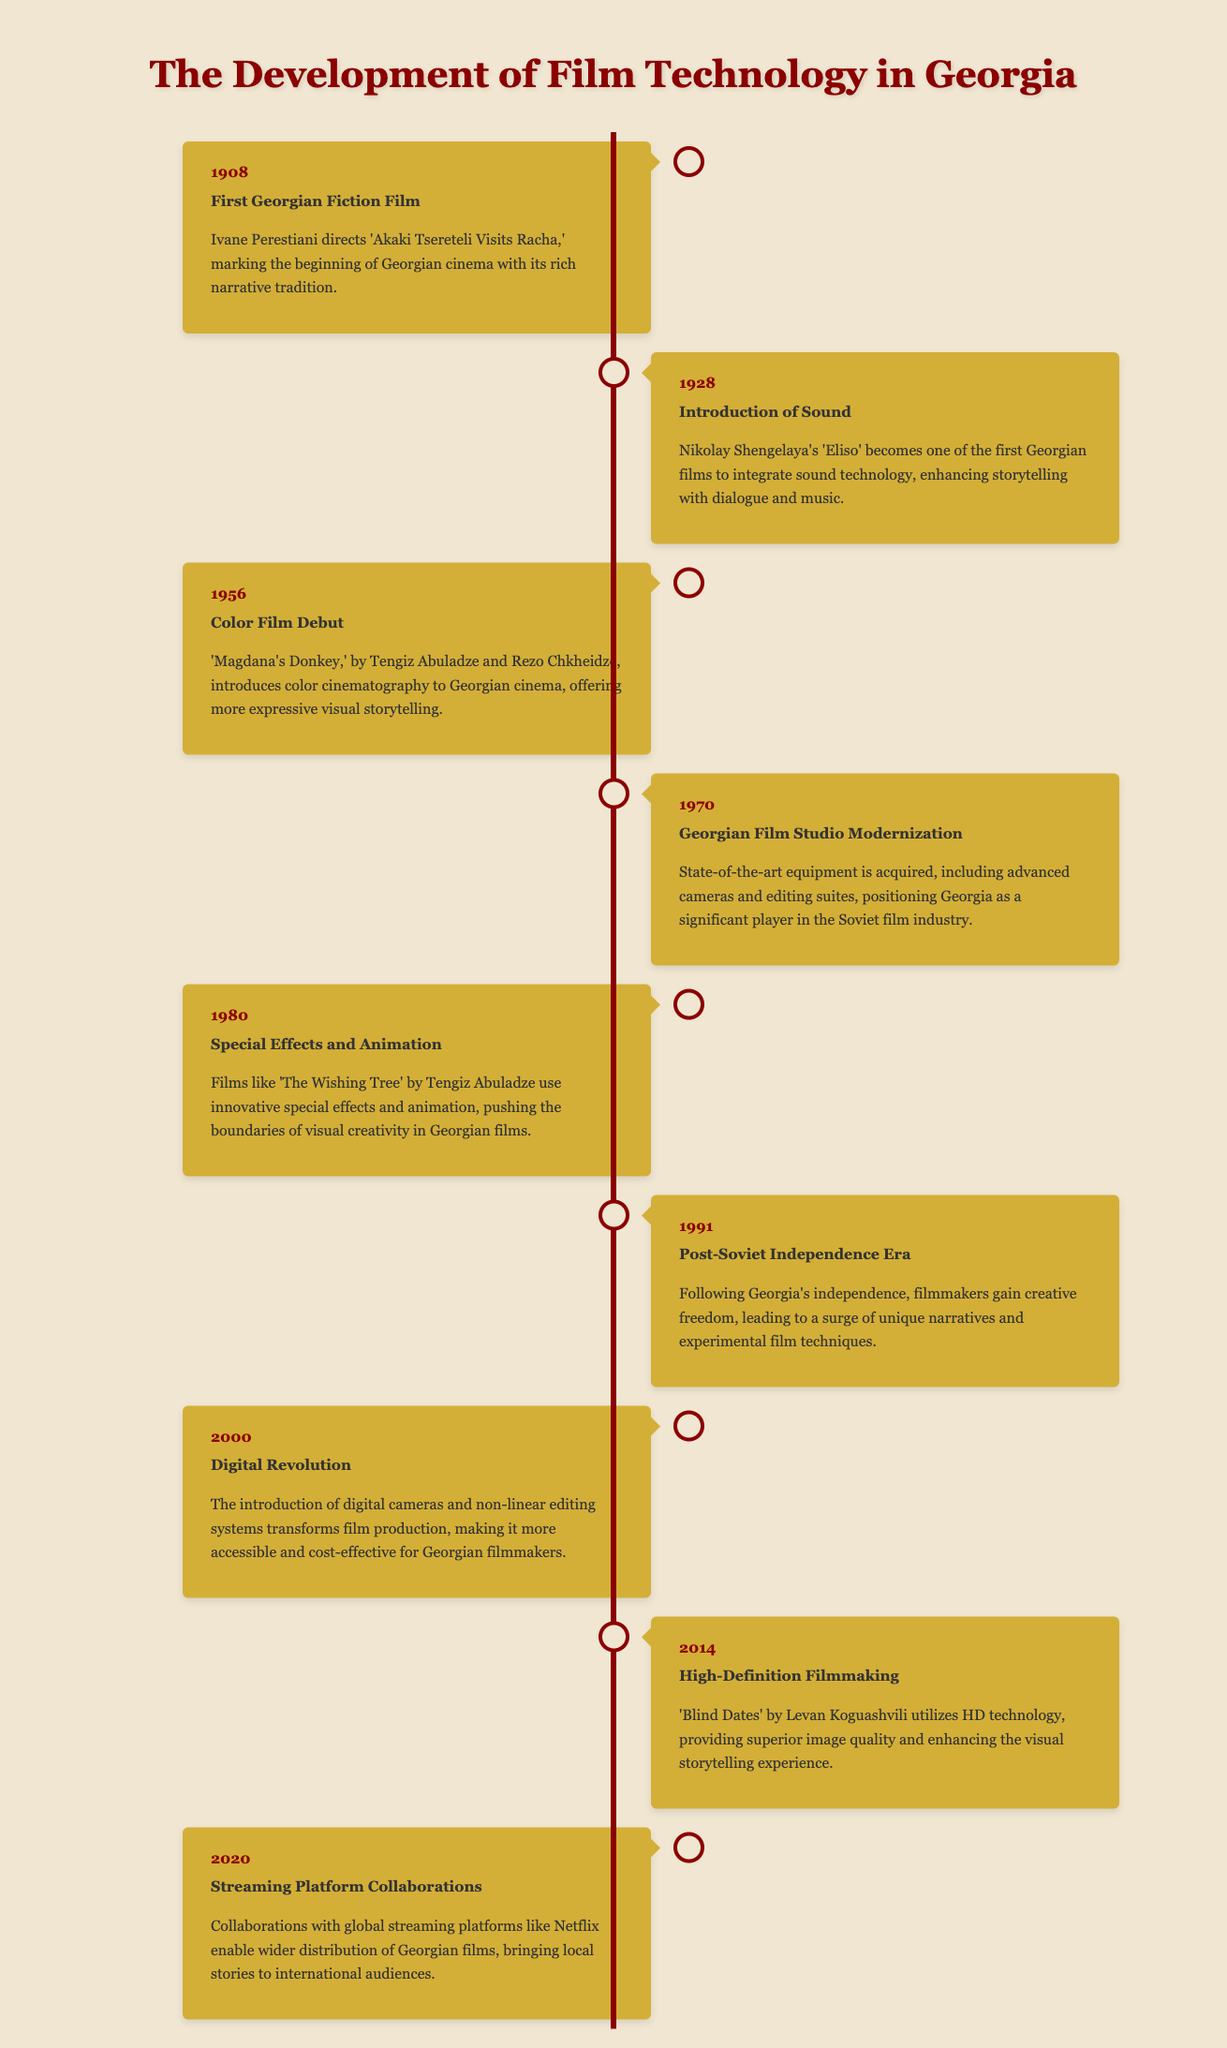What is the title of the first Georgian fiction film? The first Georgian fiction film is 'Akaki Tsereteli Visits Racha,' directed by Ivane Perestiani in 1908.
Answer: 'Akaki Tsereteli Visits Racha' In which year did Georgia integrate sound technology into films? The year when sound technology was integrated into Georgian films is 1928, with Nikolay Shengelaya's 'Eliso.'
Answer: 1928 Who directed 'Magdana's Donkey'? 'Magdana's Donkey,' which introduced color cinematography to Georgian cinema, was directed by Tengiz Abuladze and Rezo Chkheidze.
Answer: Tengiz Abuladze and Rezo Chkheidze What significant event occurred in Georgian cinema in 1991? 1991 marks the beginning of the Post-Soviet Independence Era, where filmmakers gained creative freedom.
Answer: Post-Soviet Independence Era Which technological advancement took place in Georgia's film studio in 1970? In 1970, the Georgian Film Studio underwent modernization, acquiring state-of-the-art equipment, including advanced cameras and editing suites.
Answer: Modernization What year did the digital revolution impact Georgian filmmaking? The digital revolution that transformed film production in Georgia occurred in 2000.
Answer: 2000 What is one effect of the collaborations with global streaming platforms in 2020? Collaborations with global streaming platforms expanded the distribution of Georgian films to international audiences.
Answer: Wider distribution Which film utilized HD technology in 2014? The film that utilized HD technology in 2014 is 'Blind Dates' by Levan Koguashvili.
Answer: 'Blind Dates' What kind of storytelling was enhanced with the introduction of sound in 1928? The introduction of sound technology enhanced storytelling with dialogue and music in Georgian films.
Answer: Dialogue and music 